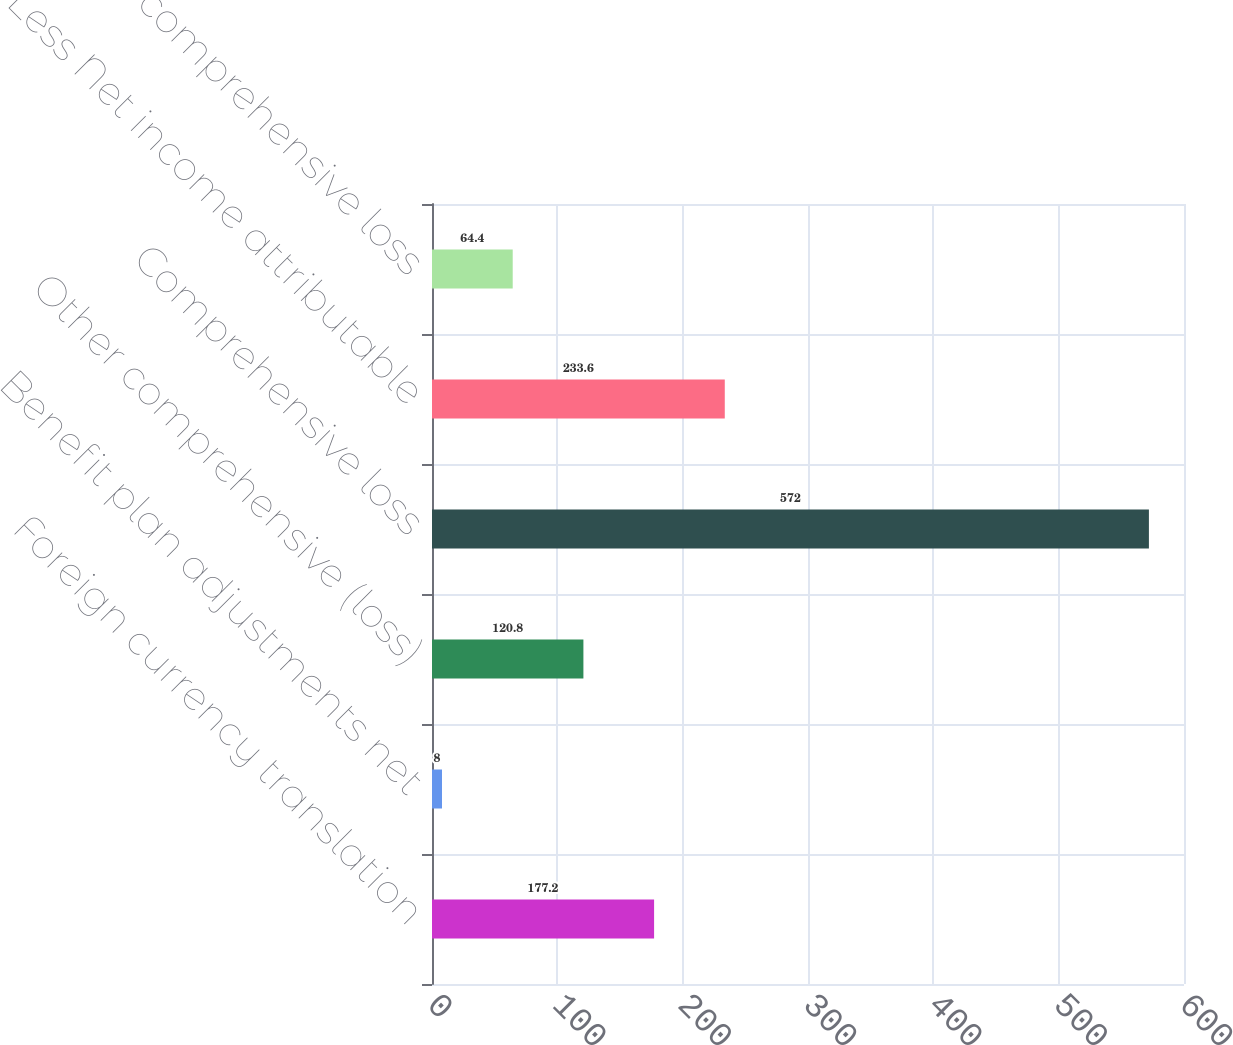Convert chart. <chart><loc_0><loc_0><loc_500><loc_500><bar_chart><fcel>Foreign currency translation<fcel>Benefit plan adjustments net<fcel>Other comprehensive (loss)<fcel>Comprehensive loss<fcel>Less Net income attributable<fcel>Less Other comprehensive loss<nl><fcel>177.2<fcel>8<fcel>120.8<fcel>572<fcel>233.6<fcel>64.4<nl></chart> 